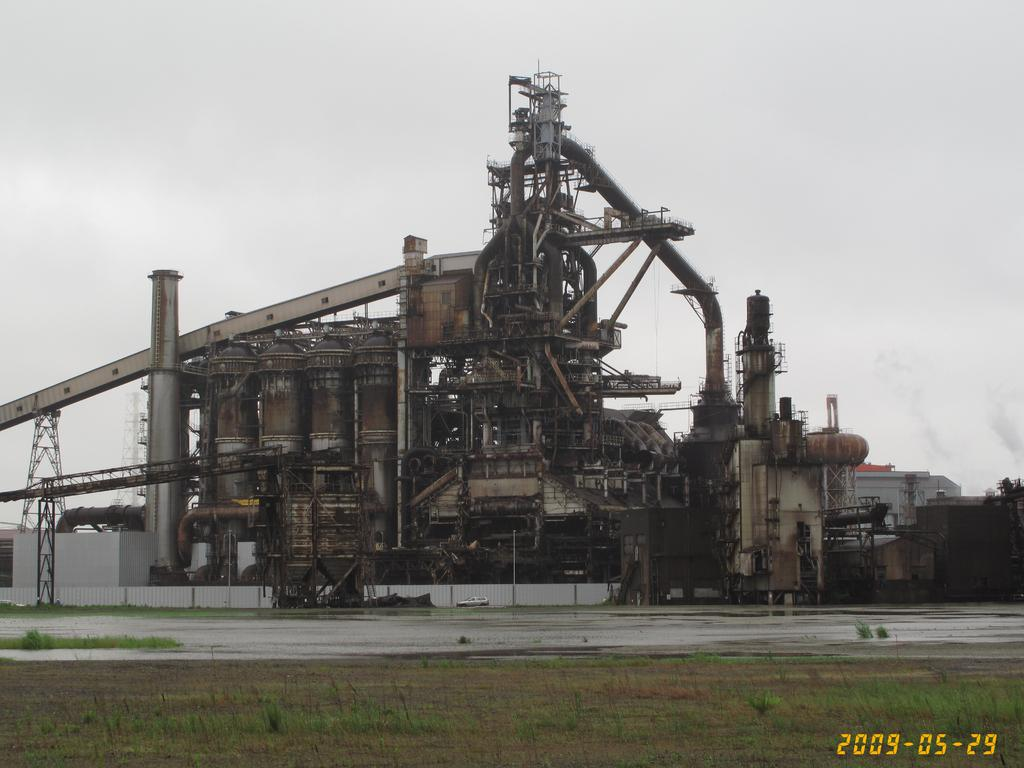What type of vegetation is in the foreground of the picture? There is grass in the foreground of the picture. What else can be seen in the foreground of the picture? There is soil and a date in the foreground of the picture. What is the main subject in the middle of the picture? There appears to be a factory with machinery in the middle of the picture. What is visible at the top of the picture? The sky is visible at the top of the picture. How many frogs are sitting on the door in the image? There are no frogs or doors present in the image. What type of pan is being used to cook in the factory in the image? There is no pan or cooking activity depicted in the image; it features a factory with machinery. 